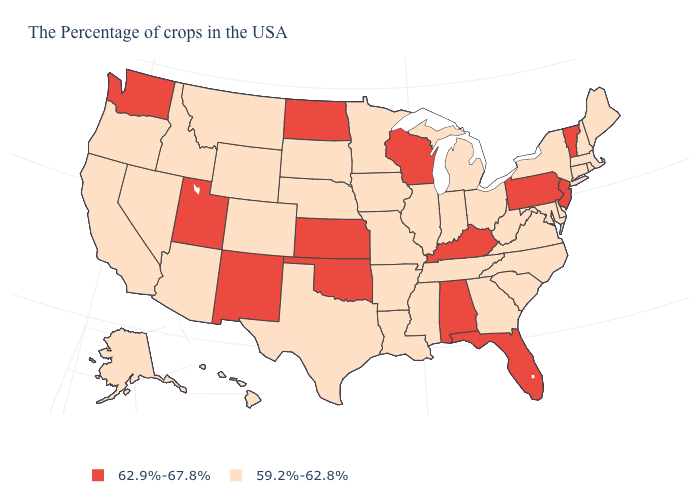Which states have the highest value in the USA?
Short answer required. Vermont, New Jersey, Pennsylvania, Florida, Kentucky, Alabama, Wisconsin, Kansas, Oklahoma, North Dakota, New Mexico, Utah, Washington. Does Maine have a lower value than Oklahoma?
Keep it brief. Yes. What is the value of Alaska?
Be succinct. 59.2%-62.8%. What is the value of Alabama?
Answer briefly. 62.9%-67.8%. What is the value of West Virginia?
Concise answer only. 59.2%-62.8%. What is the lowest value in states that border California?
Answer briefly. 59.2%-62.8%. What is the value of Maryland?
Write a very short answer. 59.2%-62.8%. Among the states that border Arizona , which have the lowest value?
Quick response, please. Colorado, Nevada, California. What is the lowest value in the USA?
Answer briefly. 59.2%-62.8%. What is the lowest value in the Northeast?
Quick response, please. 59.2%-62.8%. What is the value of California?
Concise answer only. 59.2%-62.8%. Does Oklahoma have a higher value than Maine?
Quick response, please. Yes. Name the states that have a value in the range 59.2%-62.8%?
Write a very short answer. Maine, Massachusetts, Rhode Island, New Hampshire, Connecticut, New York, Delaware, Maryland, Virginia, North Carolina, South Carolina, West Virginia, Ohio, Georgia, Michigan, Indiana, Tennessee, Illinois, Mississippi, Louisiana, Missouri, Arkansas, Minnesota, Iowa, Nebraska, Texas, South Dakota, Wyoming, Colorado, Montana, Arizona, Idaho, Nevada, California, Oregon, Alaska, Hawaii. Name the states that have a value in the range 62.9%-67.8%?
Quick response, please. Vermont, New Jersey, Pennsylvania, Florida, Kentucky, Alabama, Wisconsin, Kansas, Oklahoma, North Dakota, New Mexico, Utah, Washington. Which states have the highest value in the USA?
Give a very brief answer. Vermont, New Jersey, Pennsylvania, Florida, Kentucky, Alabama, Wisconsin, Kansas, Oklahoma, North Dakota, New Mexico, Utah, Washington. 